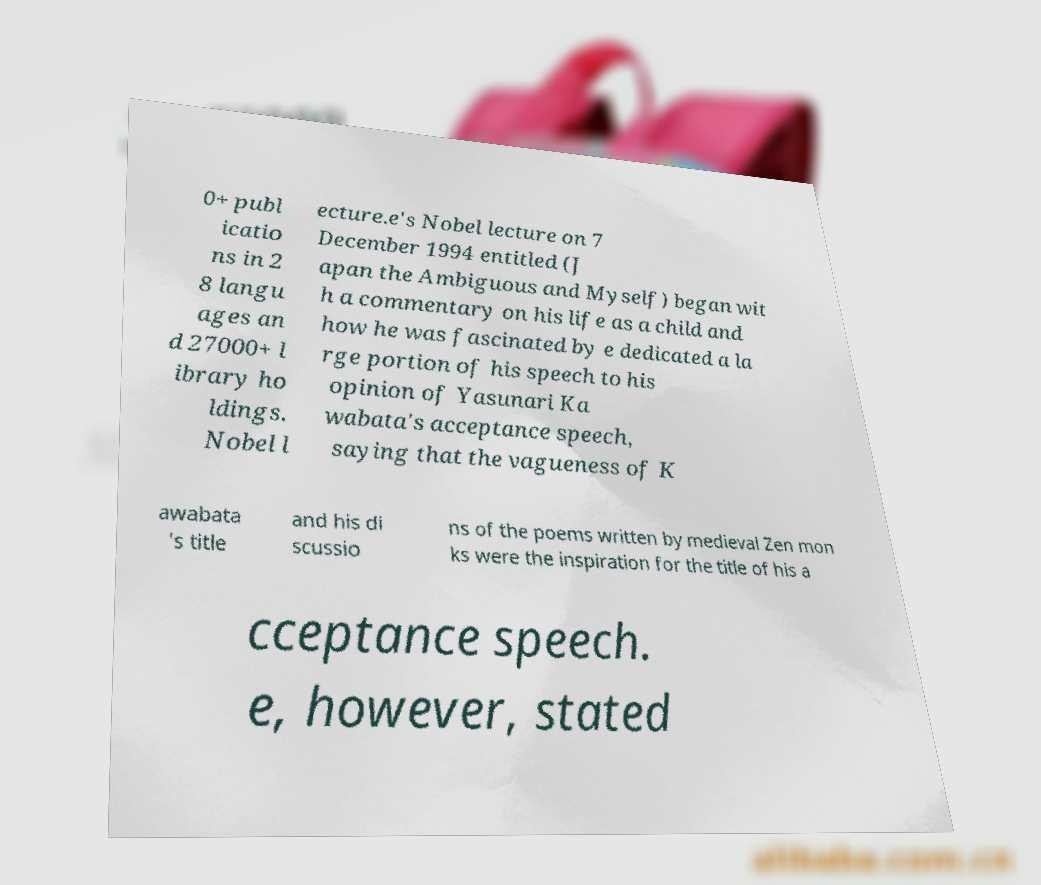There's text embedded in this image that I need extracted. Can you transcribe it verbatim? 0+ publ icatio ns in 2 8 langu ages an d 27000+ l ibrary ho ldings. Nobel l ecture.e's Nobel lecture on 7 December 1994 entitled (J apan the Ambiguous and Myself) began wit h a commentary on his life as a child and how he was fascinated by e dedicated a la rge portion of his speech to his opinion of Yasunari Ka wabata's acceptance speech, saying that the vagueness of K awabata 's title and his di scussio ns of the poems written by medieval Zen mon ks were the inspiration for the title of his a cceptance speech. e, however, stated 